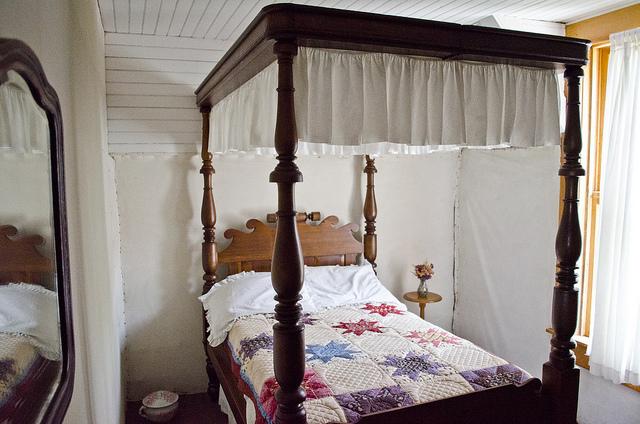What type of patterns do the pillows have?
Concise answer only. None. Is it night?
Be succinct. No. Is there flowers in the picture?
Keep it brief. Yes. What is laying on the floor next to the bed?
Write a very short answer. Trash can. 